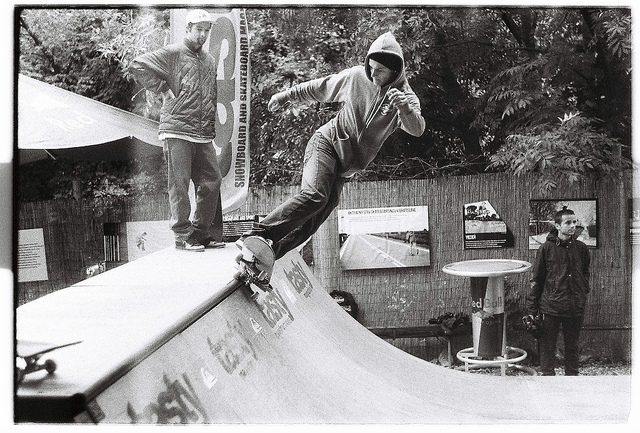Please extract the text content from this image. SNOWBOARD SKATEOARD 